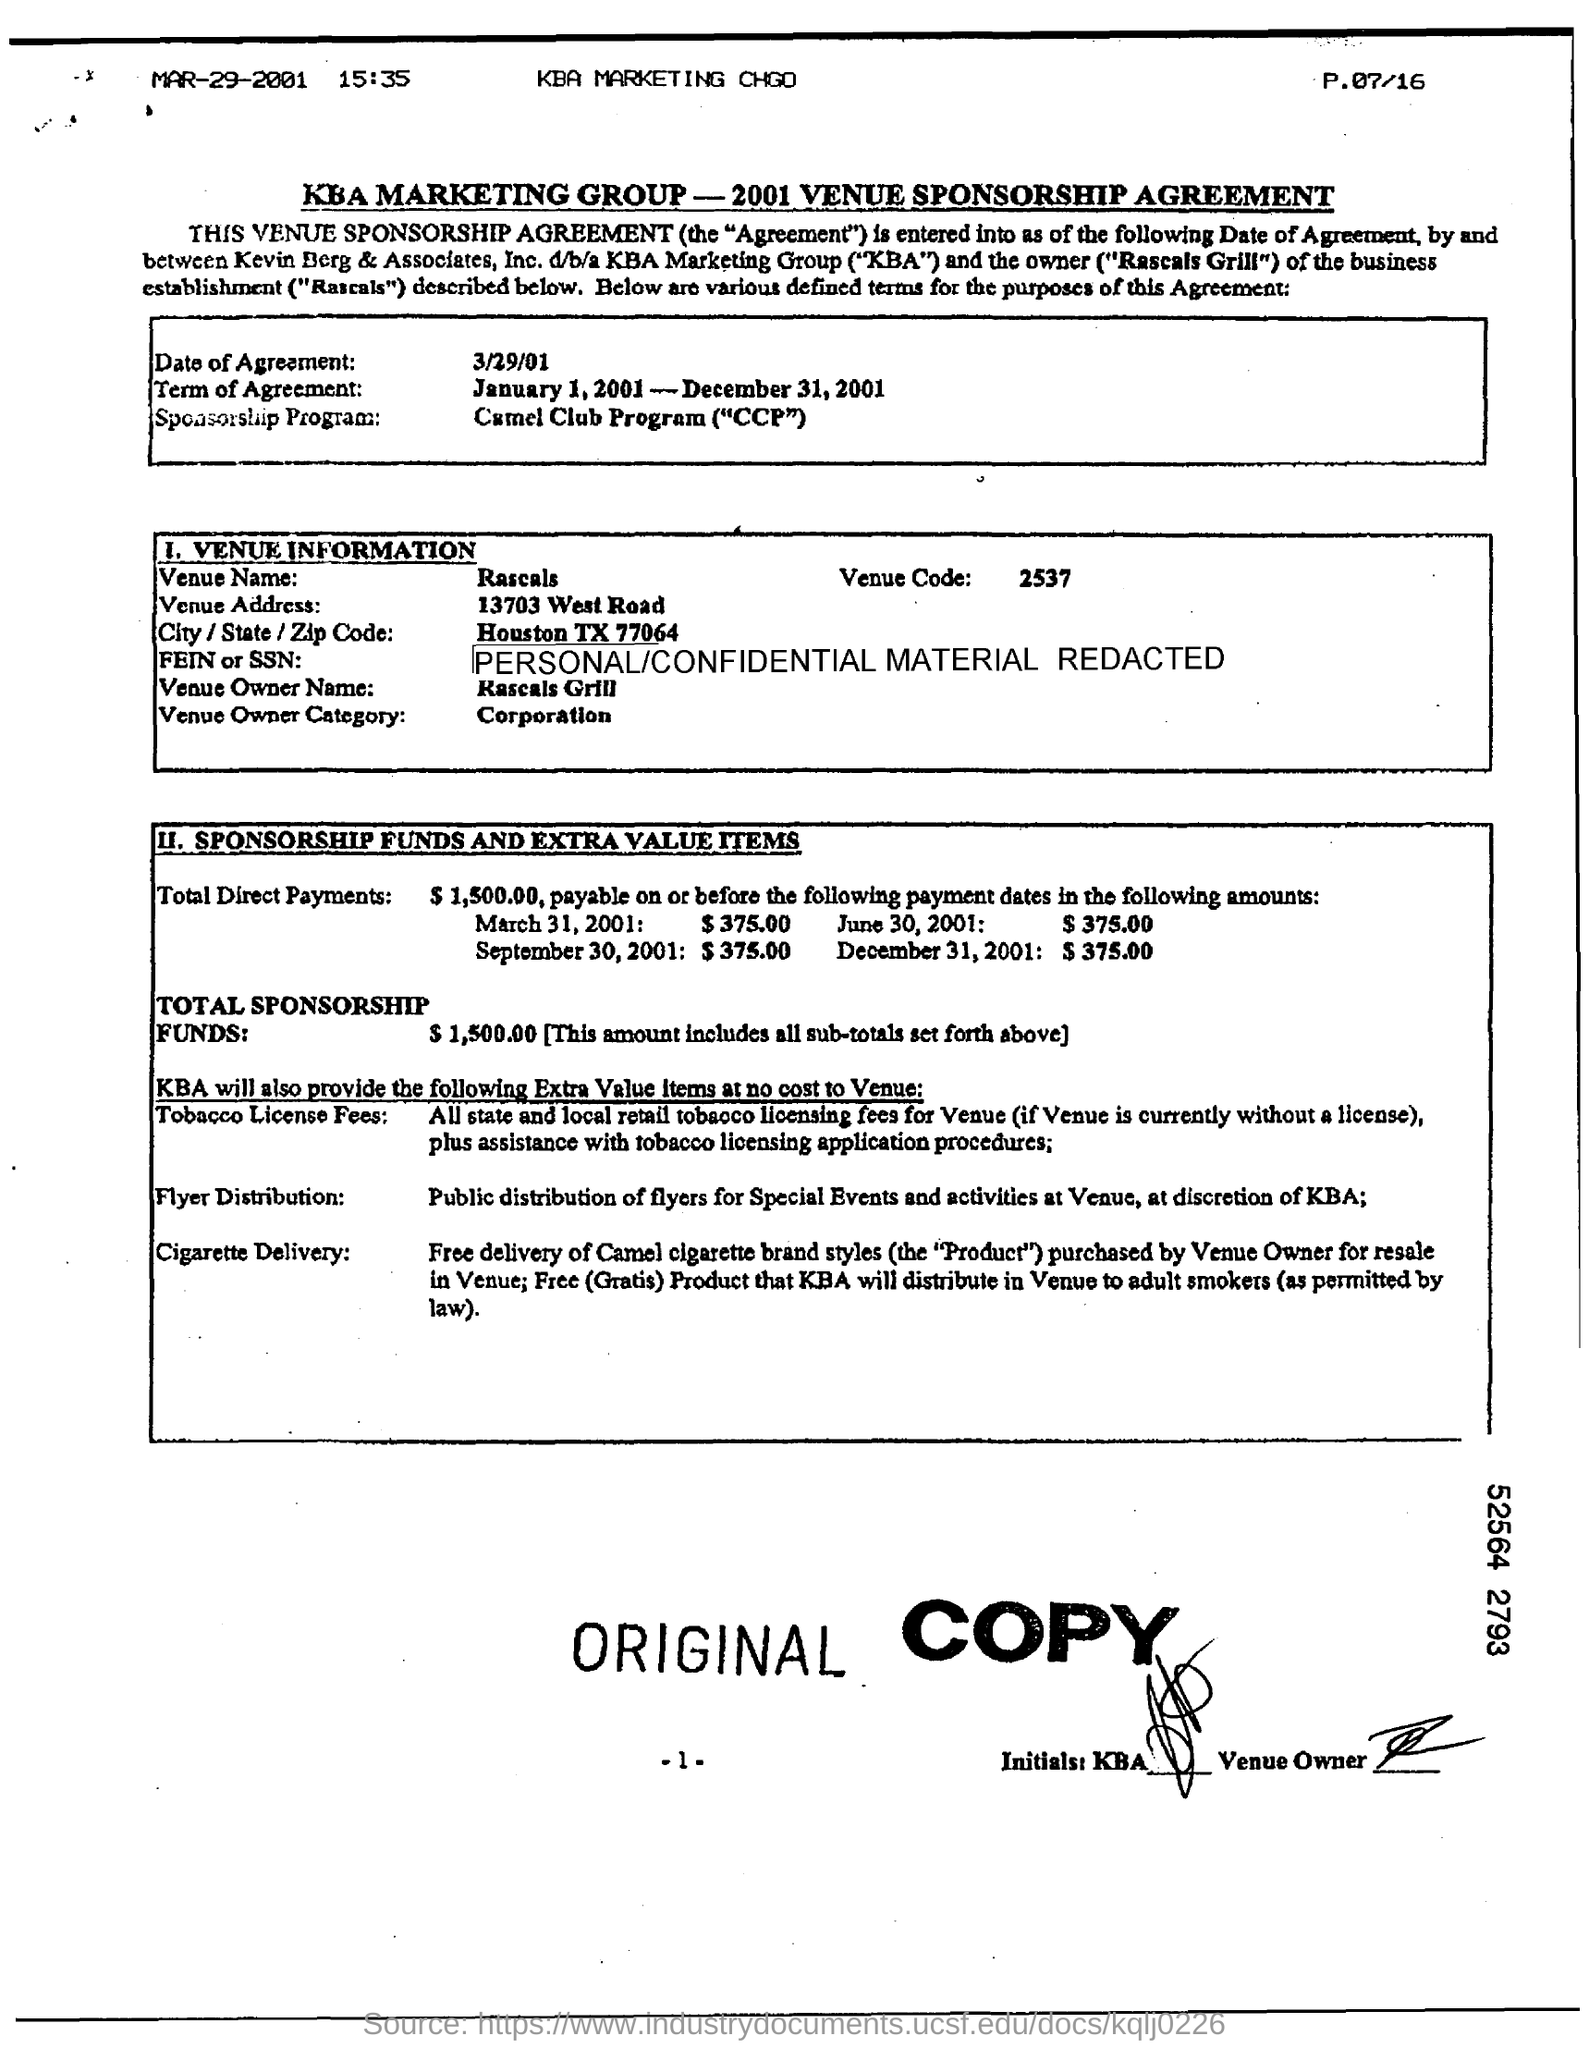Indicate a few pertinent items in this graphic. The date of agreement is March 29, 2001. The Venue Name is Rascals. The Venue Owner category refers to a type of business entity that is classified as a corporation. The Venue Owner Name is Rascals Grill. The term of agreement is from January 1, 2001 to December 31, 2001. 